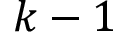Convert formula to latex. <formula><loc_0><loc_0><loc_500><loc_500>k - 1</formula> 